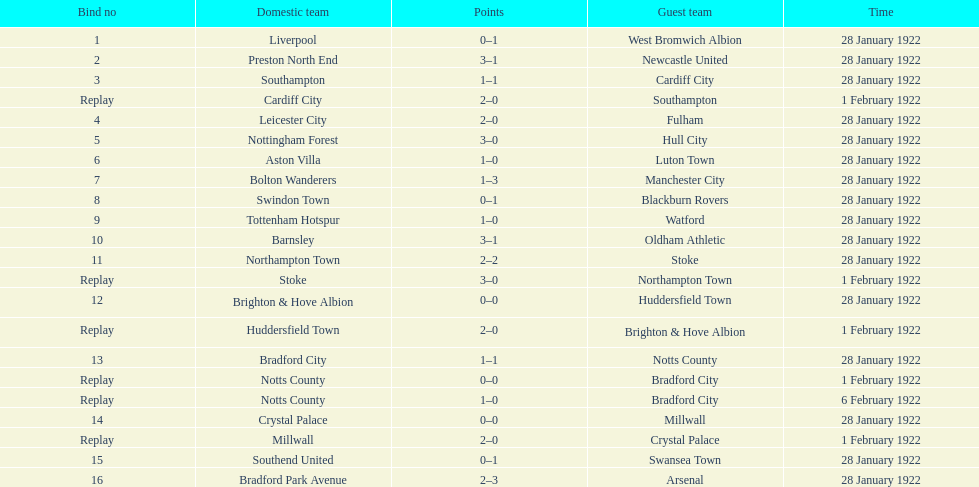Would you mind parsing the complete table? {'header': ['Bind no', 'Domestic team', 'Points', 'Guest team', 'Time'], 'rows': [['1', 'Liverpool', '0–1', 'West Bromwich Albion', '28 January 1922'], ['2', 'Preston North End', '3–1', 'Newcastle United', '28 January 1922'], ['3', 'Southampton', '1–1', 'Cardiff City', '28 January 1922'], ['Replay', 'Cardiff City', '2–0', 'Southampton', '1 February 1922'], ['4', 'Leicester City', '2–0', 'Fulham', '28 January 1922'], ['5', 'Nottingham Forest', '3–0', 'Hull City', '28 January 1922'], ['6', 'Aston Villa', '1–0', 'Luton Town', '28 January 1922'], ['7', 'Bolton Wanderers', '1–3', 'Manchester City', '28 January 1922'], ['8', 'Swindon Town', '0–1', 'Blackburn Rovers', '28 January 1922'], ['9', 'Tottenham Hotspur', '1–0', 'Watford', '28 January 1922'], ['10', 'Barnsley', '3–1', 'Oldham Athletic', '28 January 1922'], ['11', 'Northampton Town', '2–2', 'Stoke', '28 January 1922'], ['Replay', 'Stoke', '3–0', 'Northampton Town', '1 February 1922'], ['12', 'Brighton & Hove Albion', '0–0', 'Huddersfield Town', '28 January 1922'], ['Replay', 'Huddersfield Town', '2–0', 'Brighton & Hove Albion', '1 February 1922'], ['13', 'Bradford City', '1–1', 'Notts County', '28 January 1922'], ['Replay', 'Notts County', '0–0', 'Bradford City', '1 February 1922'], ['Replay', 'Notts County', '1–0', 'Bradford City', '6 February 1922'], ['14', 'Crystal Palace', '0–0', 'Millwall', '28 January 1922'], ['Replay', 'Millwall', '2–0', 'Crystal Palace', '1 February 1922'], ['15', 'Southend United', '0–1', 'Swansea Town', '28 January 1922'], ['16', 'Bradford Park Avenue', '2–3', 'Arsenal', '28 January 1922']]} What home team had the same score as aston villa on january 28th, 1922? Tottenham Hotspur. 